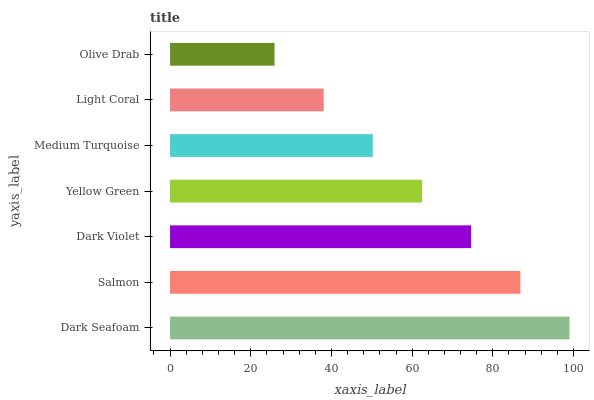Is Olive Drab the minimum?
Answer yes or no. Yes. Is Dark Seafoam the maximum?
Answer yes or no. Yes. Is Salmon the minimum?
Answer yes or no. No. Is Salmon the maximum?
Answer yes or no. No. Is Dark Seafoam greater than Salmon?
Answer yes or no. Yes. Is Salmon less than Dark Seafoam?
Answer yes or no. Yes. Is Salmon greater than Dark Seafoam?
Answer yes or no. No. Is Dark Seafoam less than Salmon?
Answer yes or no. No. Is Yellow Green the high median?
Answer yes or no. Yes. Is Yellow Green the low median?
Answer yes or no. Yes. Is Light Coral the high median?
Answer yes or no. No. Is Dark Violet the low median?
Answer yes or no. No. 